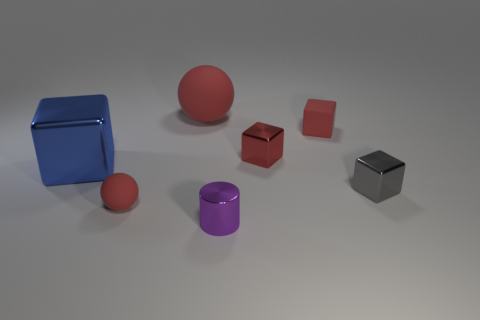Subtract all shiny cubes. How many cubes are left? 1 Subtract all blue cubes. How many cubes are left? 3 Subtract all spheres. How many objects are left? 5 Add 1 matte balls. How many objects exist? 8 Subtract all brown balls. How many gray cubes are left? 1 Subtract all red things. Subtract all matte objects. How many objects are left? 0 Add 2 red rubber cubes. How many red rubber cubes are left? 3 Add 4 tiny matte cubes. How many tiny matte cubes exist? 5 Subtract 0 gray cylinders. How many objects are left? 7 Subtract 1 balls. How many balls are left? 1 